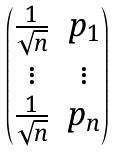Convert formula to latex. <formula><loc_0><loc_0><loc_500><loc_500>\begin{pmatrix} \frac { 1 } { \sqrt { n } } & p _ { 1 } \\ \vdots & \vdots \\ \frac { 1 } { \sqrt { n } } & p _ { n } \end{pmatrix}</formula> 